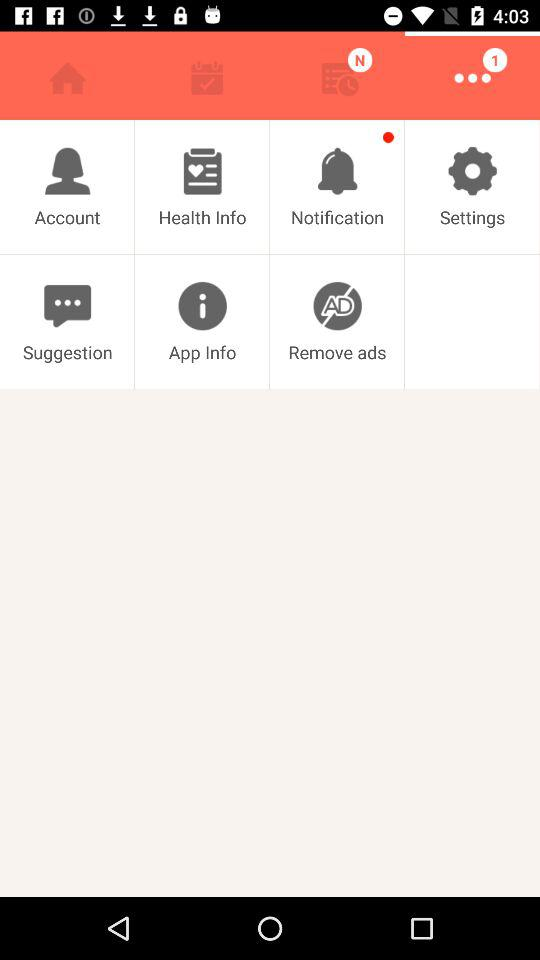What is the count of notifications? The count is 1. 